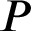<formula> <loc_0><loc_0><loc_500><loc_500>P</formula> 